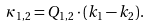Convert formula to latex. <formula><loc_0><loc_0><loc_500><loc_500>\kappa _ { 1 , 2 } = Q _ { 1 , 2 } \cdot ( k _ { 1 } - k _ { 2 } ) .</formula> 